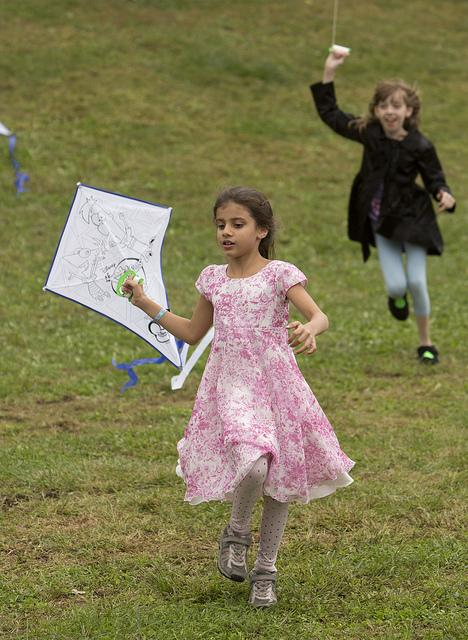What is the girl in pink wearing? dress 